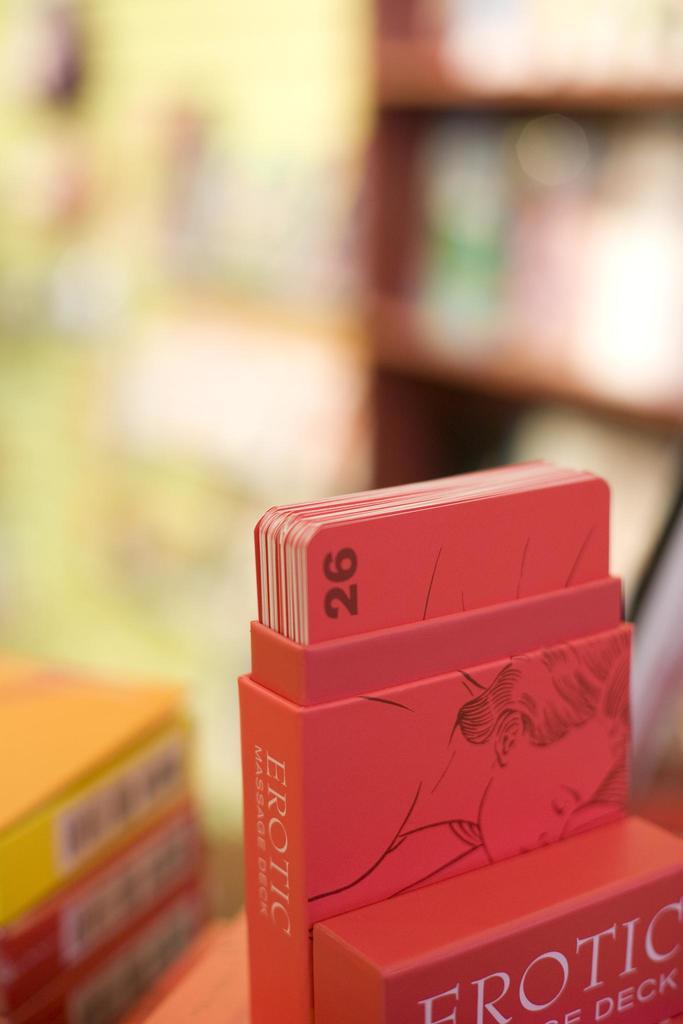What number is on this card?
Provide a short and direct response. 26. What number is on the shown card?
Offer a terse response. 26. 